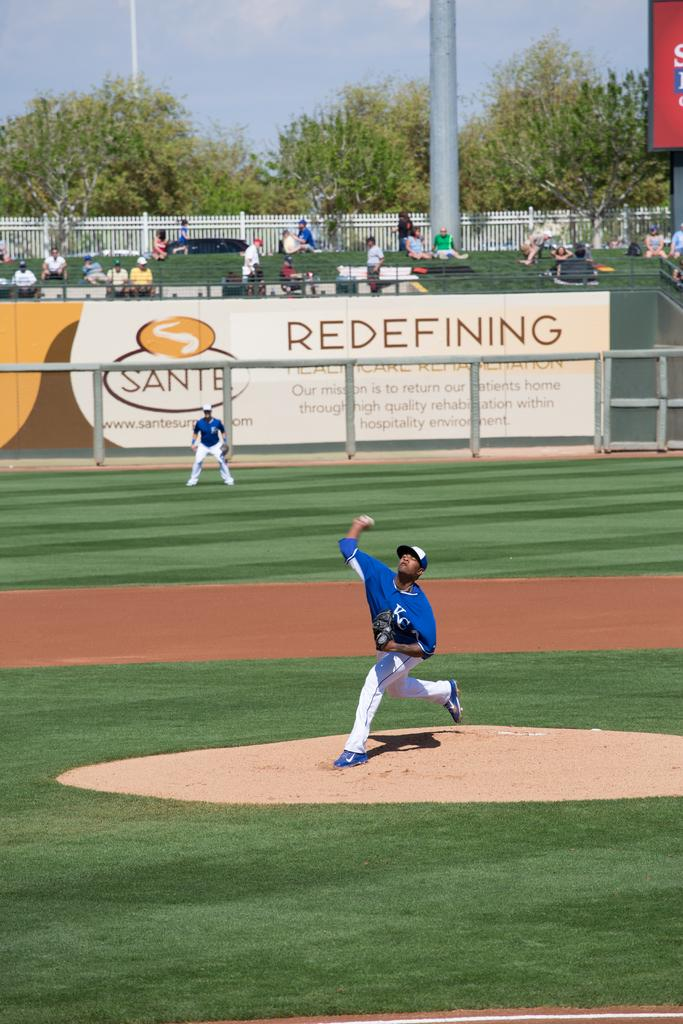<image>
Render a clear and concise summary of the photo. a pitcher throwing a ball and a sign that says redefining in the outfield 